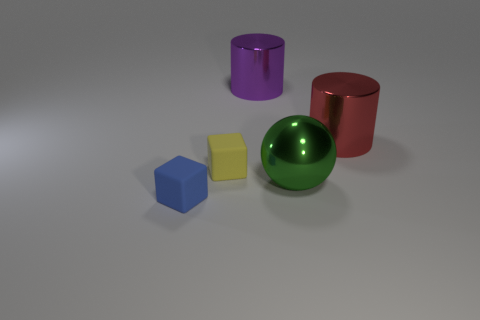How many objects are metallic spheres or large metal things in front of the small yellow rubber cube?
Provide a short and direct response. 1. What is the color of the cube that is on the left side of the yellow cube behind the metallic thing in front of the tiny yellow matte block?
Your answer should be compact. Blue. There is a matte thing that is behind the large metal sphere; what size is it?
Keep it short and to the point. Small. What number of small things are purple things or blue matte things?
Give a very brief answer. 1. The object that is both to the right of the purple cylinder and in front of the red shiny object is what color?
Give a very brief answer. Green. Are there any large yellow things that have the same shape as the big purple thing?
Ensure brevity in your answer.  No. What is the purple thing made of?
Your answer should be compact. Metal. There is a big green metallic ball; are there any balls in front of it?
Give a very brief answer. No. Is the shape of the small yellow matte thing the same as the green object?
Your response must be concise. No. What number of other objects are the same size as the blue thing?
Your answer should be compact. 1. 